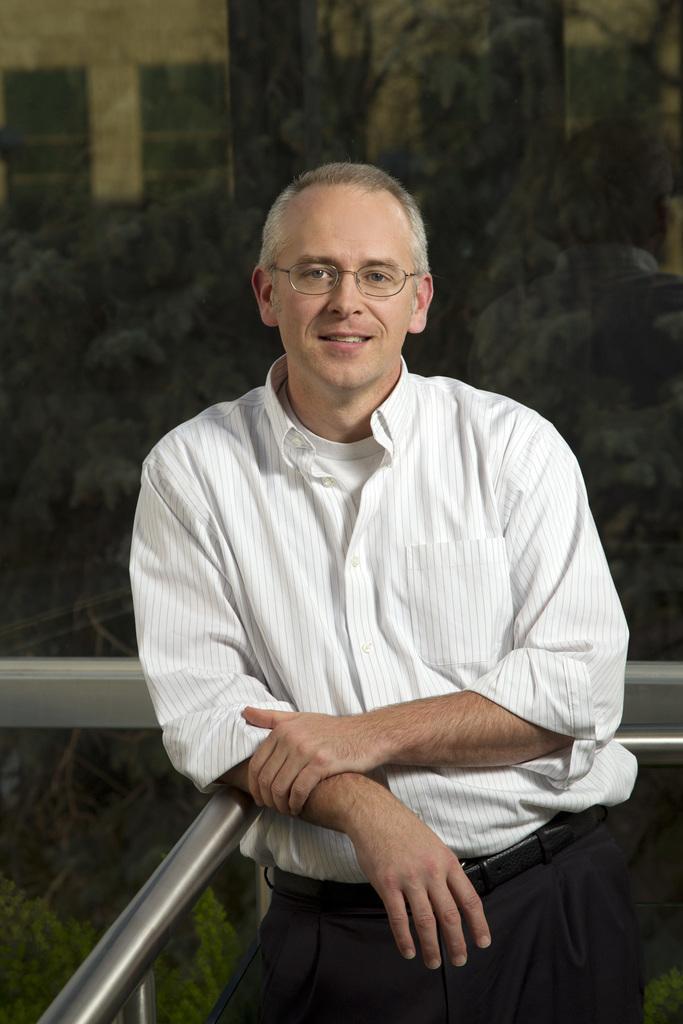Could you give a brief overview of what you see in this image? In the center of the image there is a person standing. In the background we can see trees and building. 